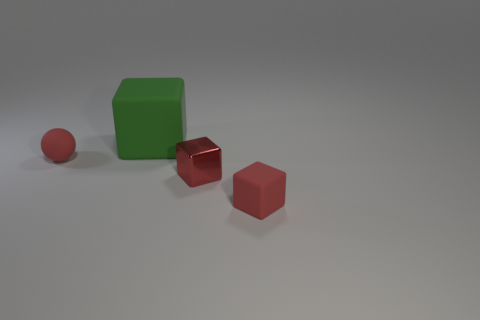How does the lighting in the scene affect the appearance of the objects? The lighting in the scene is soft and diffused, creating gentle shadows and subtle highlights on the objects. This soft lighting helps in distinguishing the materials by the way they reflect light, with matte surfaces scattering it and the metallic sphere reflecting it sharply. 